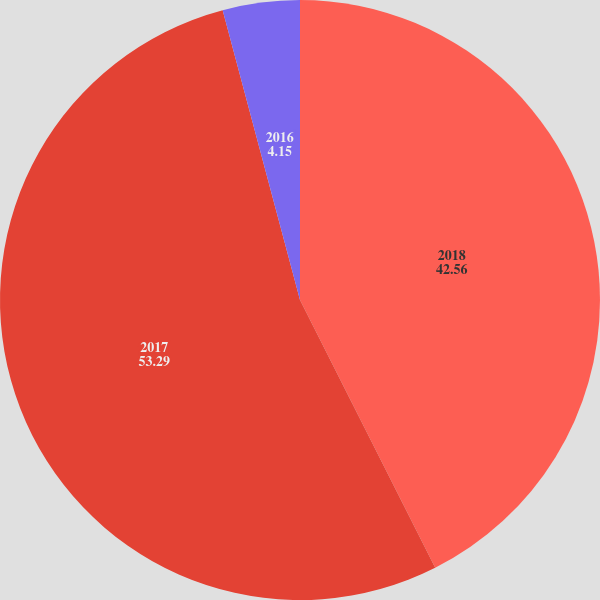<chart> <loc_0><loc_0><loc_500><loc_500><pie_chart><fcel>2018<fcel>2017<fcel>2016<nl><fcel>42.56%<fcel>53.29%<fcel>4.15%<nl></chart> 